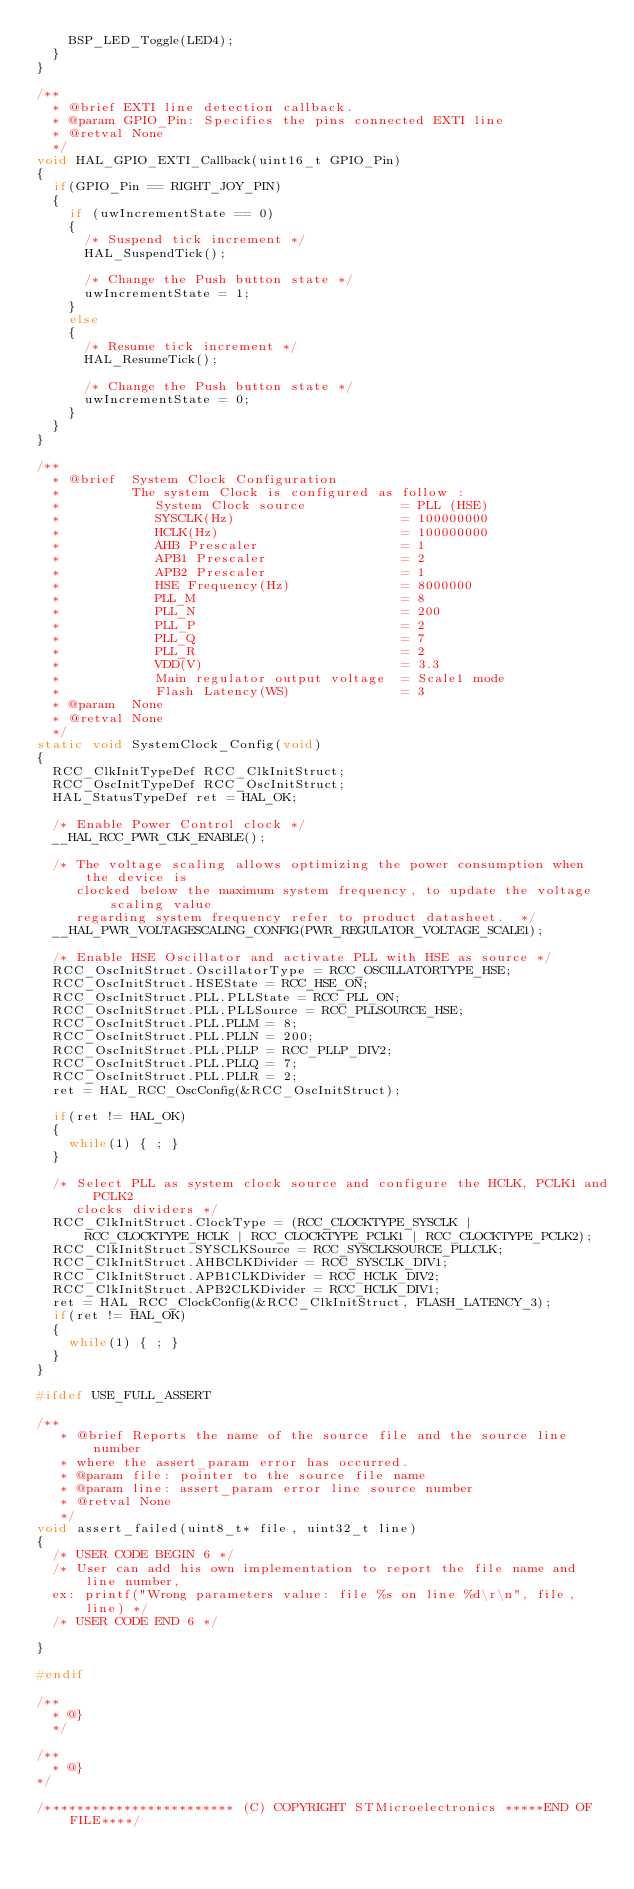Convert code to text. <code><loc_0><loc_0><loc_500><loc_500><_C_>    BSP_LED_Toggle(LED4);
  }
}

/**
  * @brief EXTI line detection callback.
  * @param GPIO_Pin: Specifies the pins connected EXTI line
  * @retval None
  */
void HAL_GPIO_EXTI_Callback(uint16_t GPIO_Pin)
{
  if(GPIO_Pin == RIGHT_JOY_PIN)
  {
    if (uwIncrementState == 0)
    {
      /* Suspend tick increment */
      HAL_SuspendTick();
      
      /* Change the Push button state */
      uwIncrementState = 1;
    }
    else
    {
      /* Resume tick increment */
      HAL_ResumeTick();
      
      /* Change the Push button state */
      uwIncrementState = 0;
    }
  }  
}

/**
  * @brief  System Clock Configuration
  *         The system Clock is configured as follow : 
  *            System Clock source            = PLL (HSE)
  *            SYSCLK(Hz)                     = 100000000
  *            HCLK(Hz)                       = 100000000
  *            AHB Prescaler                  = 1
  *            APB1 Prescaler                 = 2
  *            APB2 Prescaler                 = 1
  *            HSE Frequency(Hz)              = 8000000
  *            PLL_M                          = 8
  *            PLL_N                          = 200
  *            PLL_P                          = 2
  *            PLL_Q                          = 7
  *            PLL_R                          = 2
  *            VDD(V)                         = 3.3
  *            Main regulator output voltage  = Scale1 mode
  *            Flash Latency(WS)              = 3
  * @param  None
  * @retval None
  */
static void SystemClock_Config(void)
{
  RCC_ClkInitTypeDef RCC_ClkInitStruct;
  RCC_OscInitTypeDef RCC_OscInitStruct;
  HAL_StatusTypeDef ret = HAL_OK;

  /* Enable Power Control clock */
  __HAL_RCC_PWR_CLK_ENABLE();

  /* The voltage scaling allows optimizing the power consumption when the device is 
     clocked below the maximum system frequency, to update the voltage scaling value 
     regarding system frequency refer to product datasheet.  */
  __HAL_PWR_VOLTAGESCALING_CONFIG(PWR_REGULATOR_VOLTAGE_SCALE1);

  /* Enable HSE Oscillator and activate PLL with HSE as source */
  RCC_OscInitStruct.OscillatorType = RCC_OSCILLATORTYPE_HSE;
  RCC_OscInitStruct.HSEState = RCC_HSE_ON;
  RCC_OscInitStruct.PLL.PLLState = RCC_PLL_ON;
  RCC_OscInitStruct.PLL.PLLSource = RCC_PLLSOURCE_HSE;
  RCC_OscInitStruct.PLL.PLLM = 8;
  RCC_OscInitStruct.PLL.PLLN = 200;
  RCC_OscInitStruct.PLL.PLLP = RCC_PLLP_DIV2;
  RCC_OscInitStruct.PLL.PLLQ = 7;
  RCC_OscInitStruct.PLL.PLLR = 2;
  ret = HAL_RCC_OscConfig(&RCC_OscInitStruct);
  
  if(ret != HAL_OK)
  {
    while(1) { ; } 
  }

  /* Select PLL as system clock source and configure the HCLK, PCLK1 and PCLK2 
     clocks dividers */
  RCC_ClkInitStruct.ClockType = (RCC_CLOCKTYPE_SYSCLK | RCC_CLOCKTYPE_HCLK | RCC_CLOCKTYPE_PCLK1 | RCC_CLOCKTYPE_PCLK2);
  RCC_ClkInitStruct.SYSCLKSource = RCC_SYSCLKSOURCE_PLLCLK;
  RCC_ClkInitStruct.AHBCLKDivider = RCC_SYSCLK_DIV1;
  RCC_ClkInitStruct.APB1CLKDivider = RCC_HCLK_DIV2;  
  RCC_ClkInitStruct.APB2CLKDivider = RCC_HCLK_DIV1;  
  ret = HAL_RCC_ClockConfig(&RCC_ClkInitStruct, FLASH_LATENCY_3);
  if(ret != HAL_OK)
  {
    while(1) { ; }  
  }
}

#ifdef USE_FULL_ASSERT

/**
   * @brief Reports the name of the source file and the source line number
   * where the assert_param error has occurred.
   * @param file: pointer to the source file name
   * @param line: assert_param error line source number
   * @retval None
   */
void assert_failed(uint8_t* file, uint32_t line)
{
  /* USER CODE BEGIN 6 */
  /* User can add his own implementation to report the file name and line number,
  ex: printf("Wrong parameters value: file %s on line %d\r\n", file, line) */
  /* USER CODE END 6 */

}

#endif

/**
  * @}
  */ 

/**
  * @}
*/ 

/************************ (C) COPYRIGHT STMicroelectronics *****END OF FILE****/
</code> 